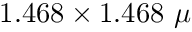Convert formula to latex. <formula><loc_0><loc_0><loc_500><loc_500>1 . 4 6 8 \times 1 . 4 6 8 \mu</formula> 